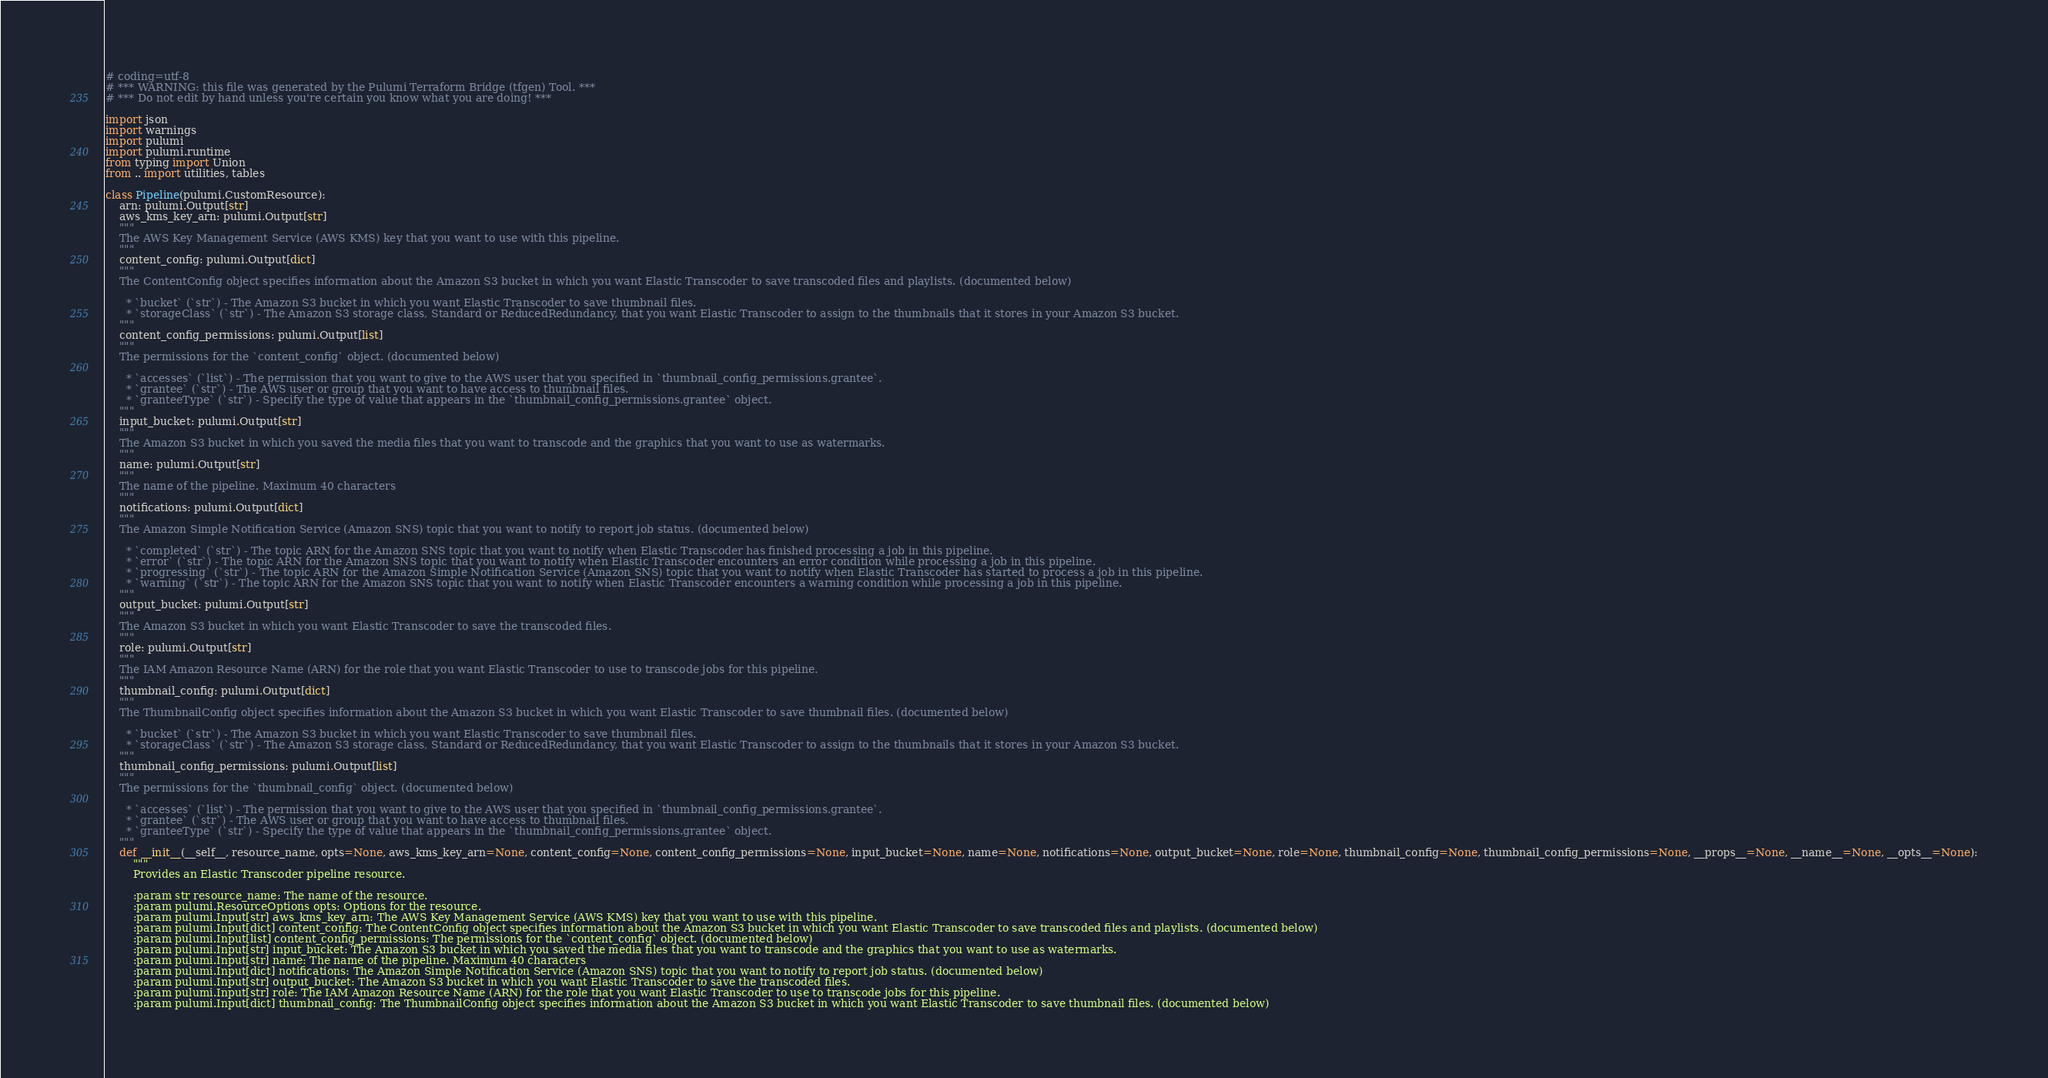<code> <loc_0><loc_0><loc_500><loc_500><_Python_># coding=utf-8
# *** WARNING: this file was generated by the Pulumi Terraform Bridge (tfgen) Tool. ***
# *** Do not edit by hand unless you're certain you know what you are doing! ***

import json
import warnings
import pulumi
import pulumi.runtime
from typing import Union
from .. import utilities, tables

class Pipeline(pulumi.CustomResource):
    arn: pulumi.Output[str]
    aws_kms_key_arn: pulumi.Output[str]
    """
    The AWS Key Management Service (AWS KMS) key that you want to use with this pipeline.
    """
    content_config: pulumi.Output[dict]
    """
    The ContentConfig object specifies information about the Amazon S3 bucket in which you want Elastic Transcoder to save transcoded files and playlists. (documented below)
    
      * `bucket` (`str`) - The Amazon S3 bucket in which you want Elastic Transcoder to save thumbnail files.
      * `storageClass` (`str`) - The Amazon S3 storage class, Standard or ReducedRedundancy, that you want Elastic Transcoder to assign to the thumbnails that it stores in your Amazon S3 bucket.
    """
    content_config_permissions: pulumi.Output[list]
    """
    The permissions for the `content_config` object. (documented below)
    
      * `accesses` (`list`) - The permission that you want to give to the AWS user that you specified in `thumbnail_config_permissions.grantee`.
      * `grantee` (`str`) - The AWS user or group that you want to have access to thumbnail files.
      * `granteeType` (`str`) - Specify the type of value that appears in the `thumbnail_config_permissions.grantee` object.
    """
    input_bucket: pulumi.Output[str]
    """
    The Amazon S3 bucket in which you saved the media files that you want to transcode and the graphics that you want to use as watermarks.
    """
    name: pulumi.Output[str]
    """
    The name of the pipeline. Maximum 40 characters
    """
    notifications: pulumi.Output[dict]
    """
    The Amazon Simple Notification Service (Amazon SNS) topic that you want to notify to report job status. (documented below)
    
      * `completed` (`str`) - The topic ARN for the Amazon SNS topic that you want to notify when Elastic Transcoder has finished processing a job in this pipeline.
      * `error` (`str`) - The topic ARN for the Amazon SNS topic that you want to notify when Elastic Transcoder encounters an error condition while processing a job in this pipeline.
      * `progressing` (`str`) - The topic ARN for the Amazon Simple Notification Service (Amazon SNS) topic that you want to notify when Elastic Transcoder has started to process a job in this pipeline.
      * `warning` (`str`) - The topic ARN for the Amazon SNS topic that you want to notify when Elastic Transcoder encounters a warning condition while processing a job in this pipeline.
    """
    output_bucket: pulumi.Output[str]
    """
    The Amazon S3 bucket in which you want Elastic Transcoder to save the transcoded files.
    """
    role: pulumi.Output[str]
    """
    The IAM Amazon Resource Name (ARN) for the role that you want Elastic Transcoder to use to transcode jobs for this pipeline.
    """
    thumbnail_config: pulumi.Output[dict]
    """
    The ThumbnailConfig object specifies information about the Amazon S3 bucket in which you want Elastic Transcoder to save thumbnail files. (documented below)
    
      * `bucket` (`str`) - The Amazon S3 bucket in which you want Elastic Transcoder to save thumbnail files.
      * `storageClass` (`str`) - The Amazon S3 storage class, Standard or ReducedRedundancy, that you want Elastic Transcoder to assign to the thumbnails that it stores in your Amazon S3 bucket.
    """
    thumbnail_config_permissions: pulumi.Output[list]
    """
    The permissions for the `thumbnail_config` object. (documented below)
    
      * `accesses` (`list`) - The permission that you want to give to the AWS user that you specified in `thumbnail_config_permissions.grantee`.
      * `grantee` (`str`) - The AWS user or group that you want to have access to thumbnail files.
      * `granteeType` (`str`) - Specify the type of value that appears in the `thumbnail_config_permissions.grantee` object.
    """
    def __init__(__self__, resource_name, opts=None, aws_kms_key_arn=None, content_config=None, content_config_permissions=None, input_bucket=None, name=None, notifications=None, output_bucket=None, role=None, thumbnail_config=None, thumbnail_config_permissions=None, __props__=None, __name__=None, __opts__=None):
        """
        Provides an Elastic Transcoder pipeline resource.
        
        :param str resource_name: The name of the resource.
        :param pulumi.ResourceOptions opts: Options for the resource.
        :param pulumi.Input[str] aws_kms_key_arn: The AWS Key Management Service (AWS KMS) key that you want to use with this pipeline.
        :param pulumi.Input[dict] content_config: The ContentConfig object specifies information about the Amazon S3 bucket in which you want Elastic Transcoder to save transcoded files and playlists. (documented below)
        :param pulumi.Input[list] content_config_permissions: The permissions for the `content_config` object. (documented below)
        :param pulumi.Input[str] input_bucket: The Amazon S3 bucket in which you saved the media files that you want to transcode and the graphics that you want to use as watermarks.
        :param pulumi.Input[str] name: The name of the pipeline. Maximum 40 characters
        :param pulumi.Input[dict] notifications: The Amazon Simple Notification Service (Amazon SNS) topic that you want to notify to report job status. (documented below)
        :param pulumi.Input[str] output_bucket: The Amazon S3 bucket in which you want Elastic Transcoder to save the transcoded files.
        :param pulumi.Input[str] role: The IAM Amazon Resource Name (ARN) for the role that you want Elastic Transcoder to use to transcode jobs for this pipeline.
        :param pulumi.Input[dict] thumbnail_config: The ThumbnailConfig object specifies information about the Amazon S3 bucket in which you want Elastic Transcoder to save thumbnail files. (documented below)</code> 